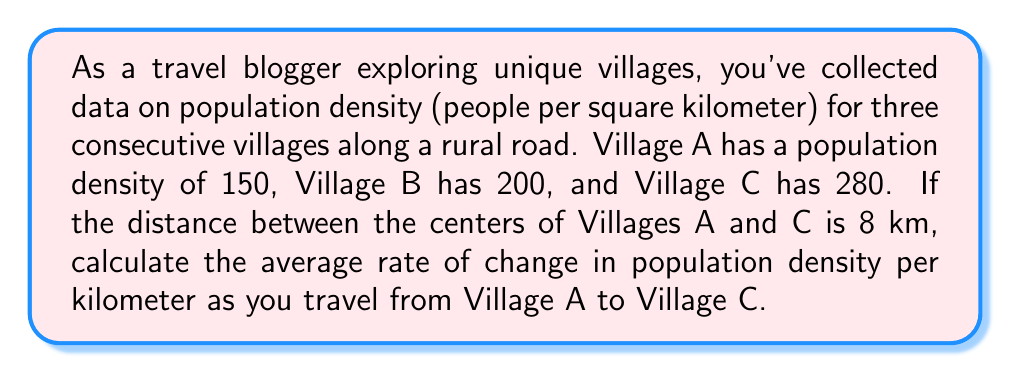Solve this math problem. To solve this problem, we'll use the concept of average rate of change from calculus. The average rate of change is given by the formula:

$$\text{Average rate of change} = \frac{\text{Change in y}}{\text{Change in x}}$$

In this case:
- y represents the population density
- x represents the distance

1. Calculate the change in population density:
   $$\Delta y = \text{Density of Village C} - \text{Density of Village A}$$
   $$\Delta y = 280 - 150 = 130 \text{ people/km}^2$$

2. The change in distance is given:
   $$\Delta x = 8 \text{ km}$$

3. Apply the average rate of change formula:
   $$\text{Average rate of change} = \frac{\Delta y}{\Delta x} = \frac{130 \text{ people/km}^2}{8 \text{ km}}$$

4. Simplify:
   $$\text{Average rate of change} = 16.25 \text{ people/km}^3$$

This result represents the average increase in population density per kilometer as you travel from Village A to Village C.
Answer: $16.25 \text{ people/km}^3$ 